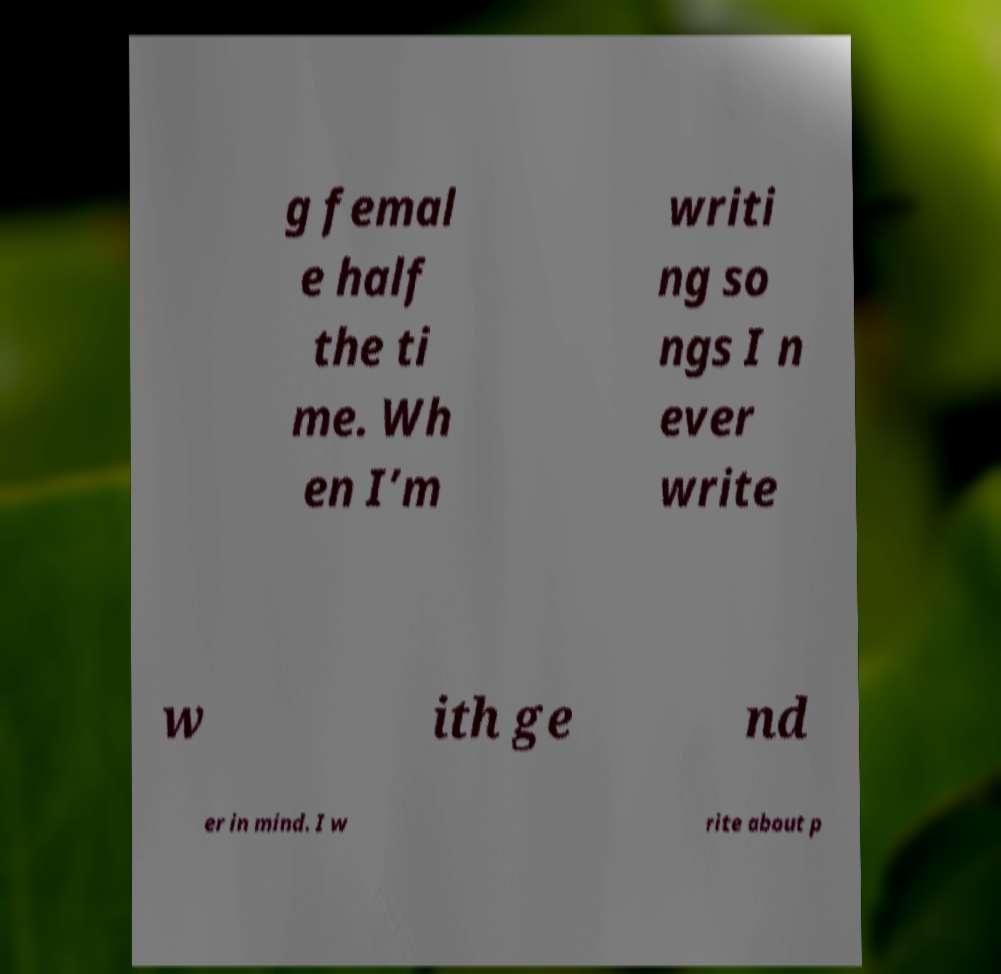For documentation purposes, I need the text within this image transcribed. Could you provide that? g femal e half the ti me. Wh en I’m writi ng so ngs I n ever write w ith ge nd er in mind. I w rite about p 